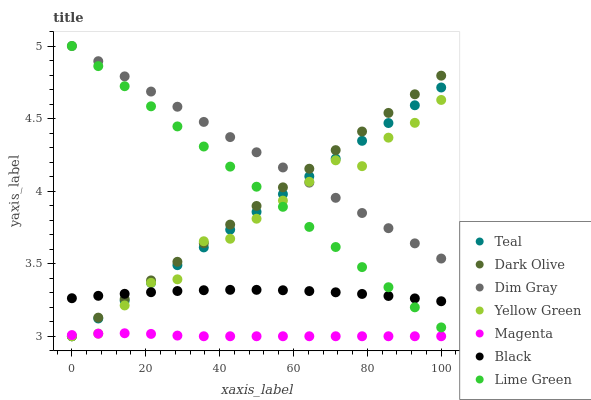Does Magenta have the minimum area under the curve?
Answer yes or no. Yes. Does Dim Gray have the maximum area under the curve?
Answer yes or no. Yes. Does Yellow Green have the minimum area under the curve?
Answer yes or no. No. Does Yellow Green have the maximum area under the curve?
Answer yes or no. No. Is Teal the smoothest?
Answer yes or no. Yes. Is Yellow Green the roughest?
Answer yes or no. Yes. Is Dark Olive the smoothest?
Answer yes or no. No. Is Dark Olive the roughest?
Answer yes or no. No. Does Yellow Green have the lowest value?
Answer yes or no. Yes. Does Black have the lowest value?
Answer yes or no. No. Does Lime Green have the highest value?
Answer yes or no. Yes. Does Yellow Green have the highest value?
Answer yes or no. No. Is Magenta less than Dim Gray?
Answer yes or no. Yes. Is Dim Gray greater than Black?
Answer yes or no. Yes. Does Teal intersect Black?
Answer yes or no. Yes. Is Teal less than Black?
Answer yes or no. No. Is Teal greater than Black?
Answer yes or no. No. Does Magenta intersect Dim Gray?
Answer yes or no. No. 